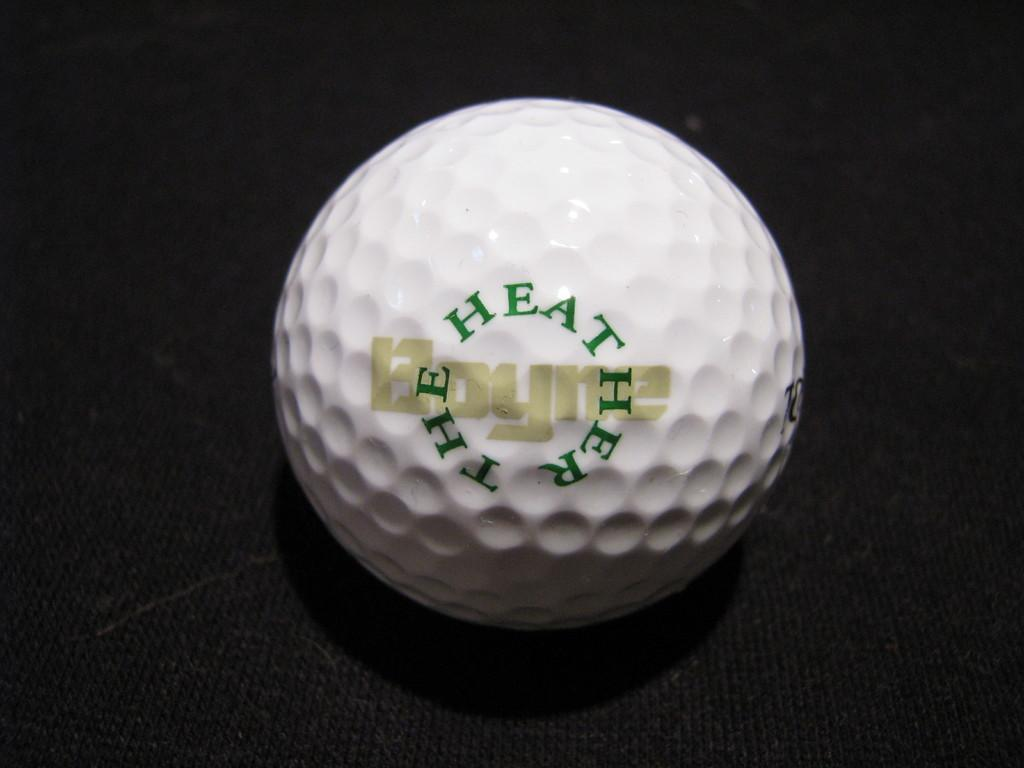What is the main object in the image? There is a golf ball in the image. What is the color of the surface the golf ball is on? The golf ball is on a black surface. Is there a receipt for the golf ball in the image? There is no mention of a receipt in the image, and it is not visible in the provided facts. 